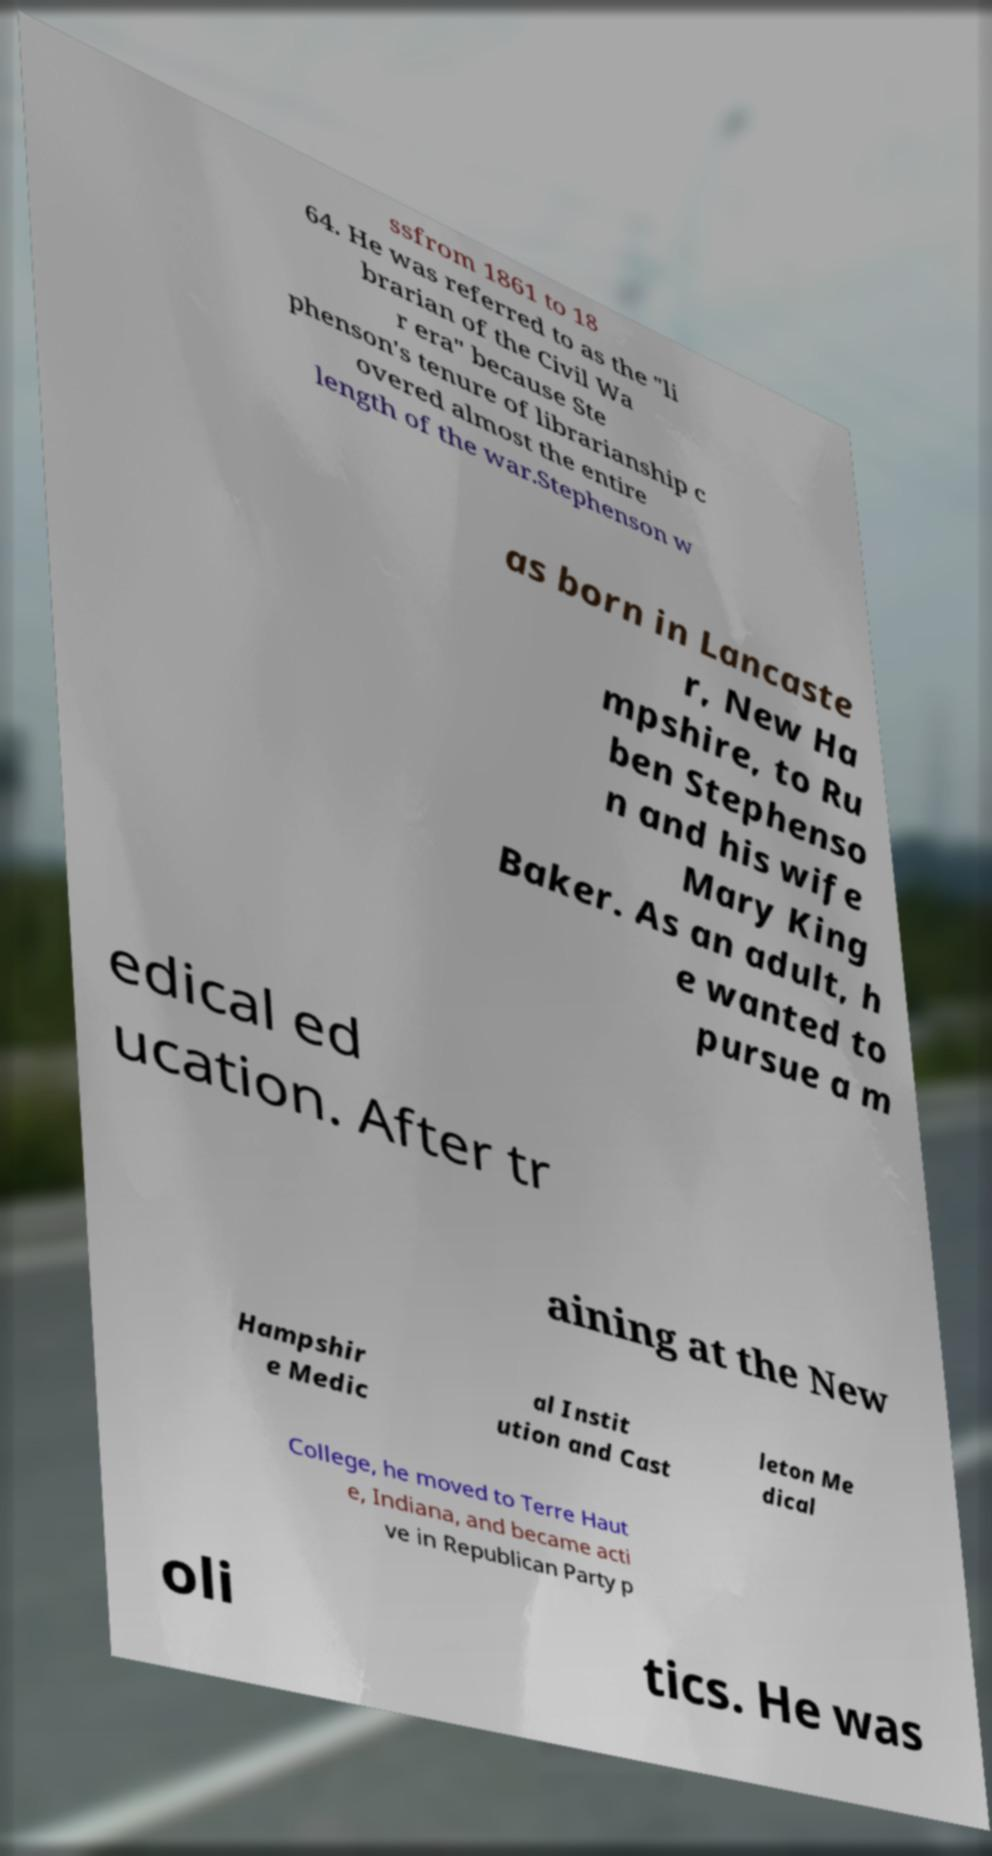Please read and relay the text visible in this image. What does it say? ssfrom 1861 to 18 64. He was referred to as the "li brarian of the Civil Wa r era" because Ste phenson's tenure of librarianship c overed almost the entire length of the war.Stephenson w as born in Lancaste r, New Ha mpshire, to Ru ben Stephenso n and his wife Mary King Baker. As an adult, h e wanted to pursue a m edical ed ucation. After tr aining at the New Hampshir e Medic al Instit ution and Cast leton Me dical College, he moved to Terre Haut e, Indiana, and became acti ve in Republican Party p oli tics. He was 